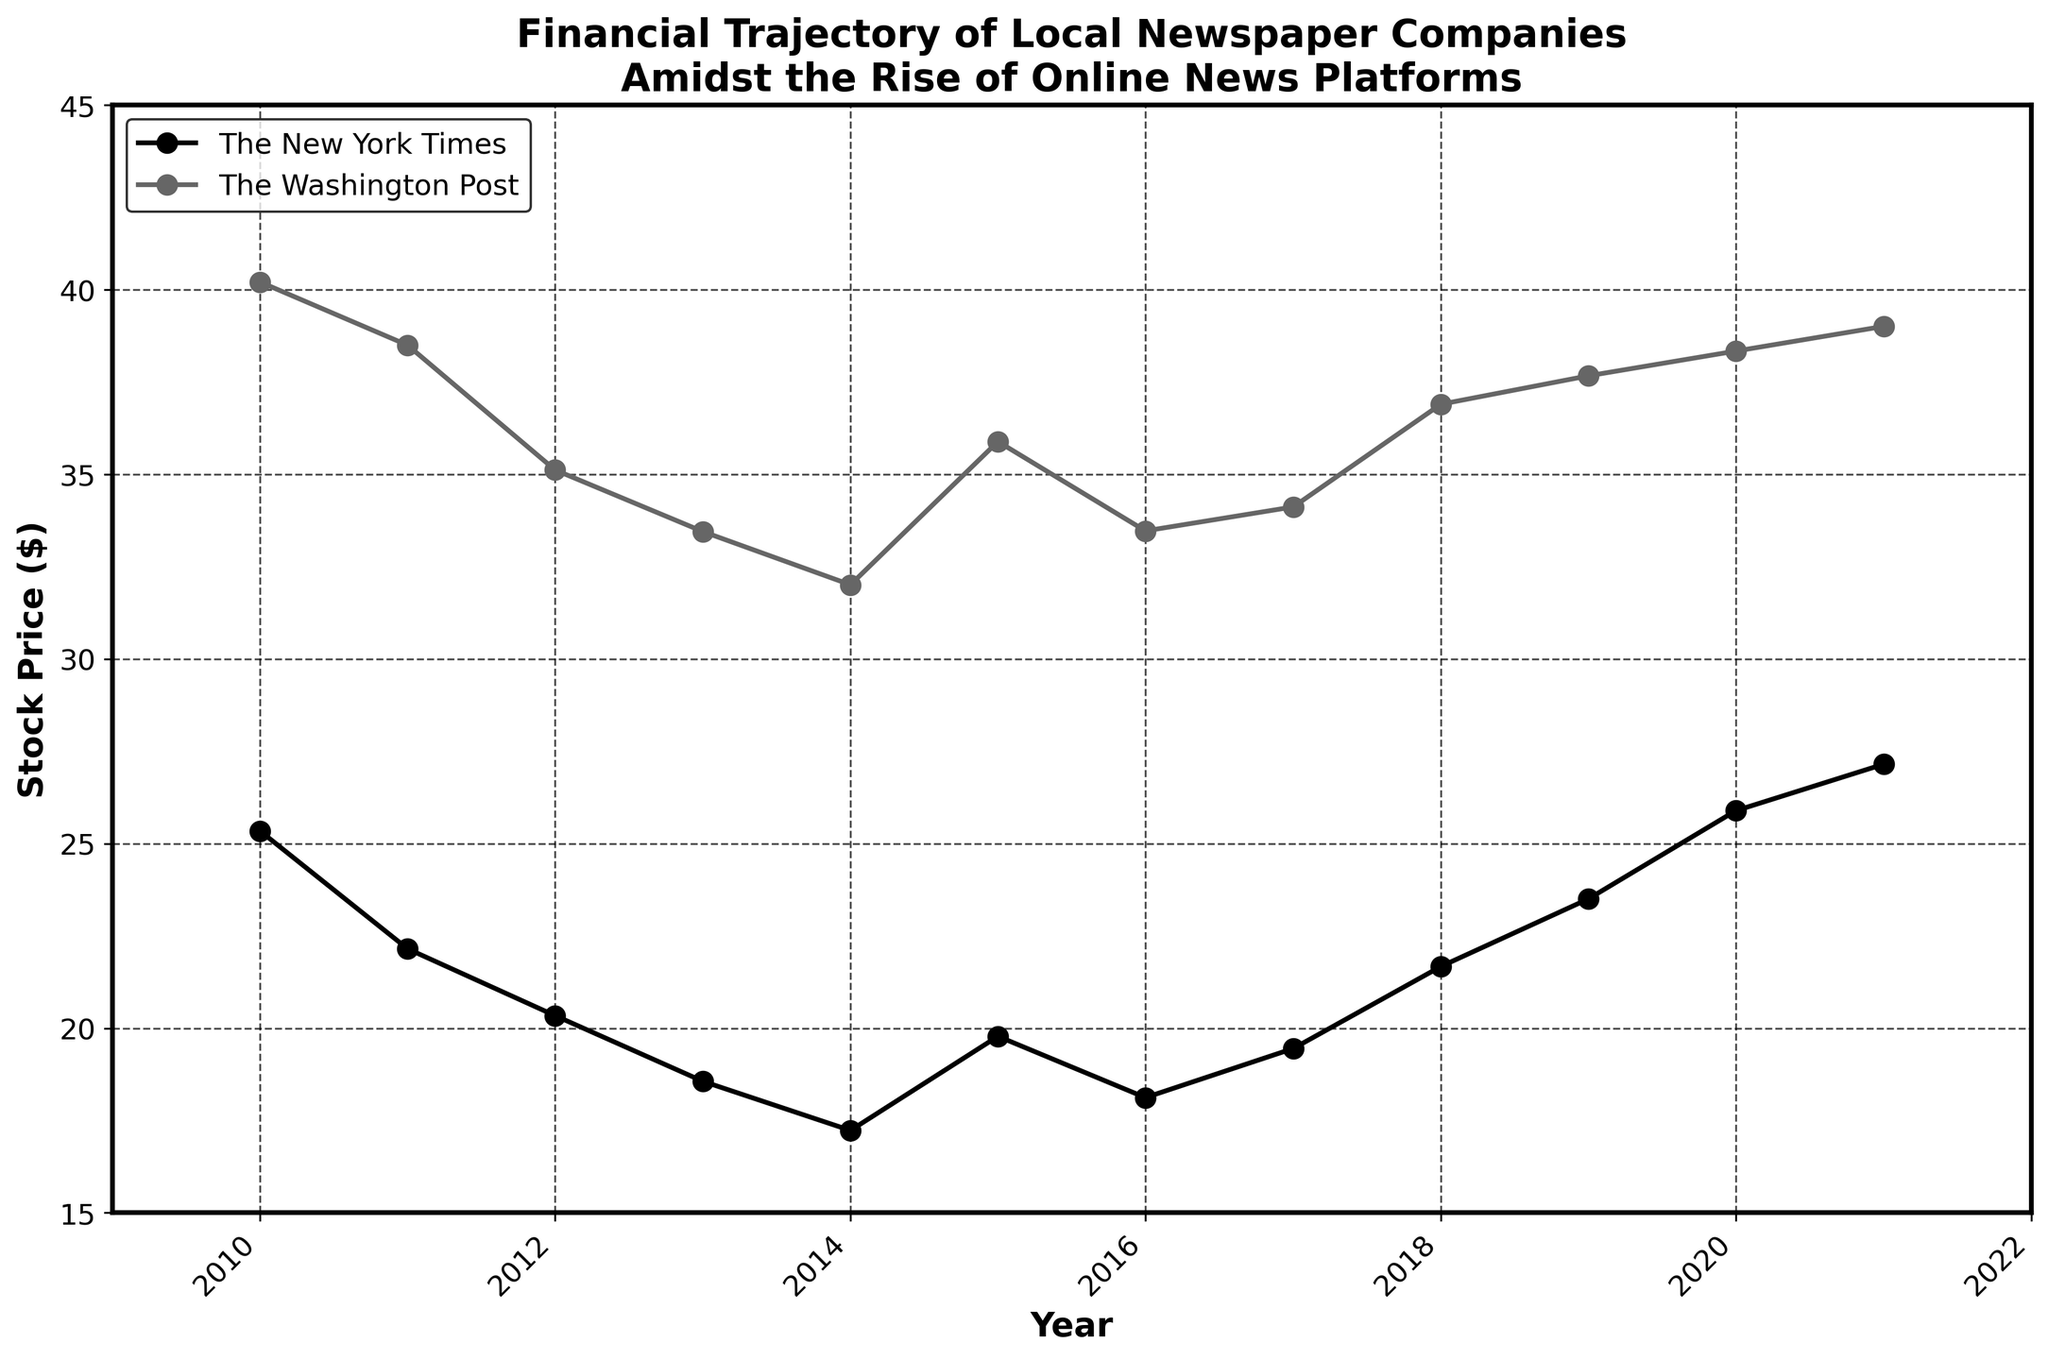what is the overall trend for The New York Times' stock price from 2010 to 2021? The plot shows the stock prices for The New York Times from 2010 to 2021. Visually tracing the curve, we observe that the stock price initially declines from 2010 to 2014, reaching a low around 2014. From 2015 onward, the price shows an upward trend, ending higher in 2021 compared to 2010.
Answer: The overall trend is a decline followed by an upward trend What's the lowest recorded stock price for The Washington Post during the observation period? By examining the plot for The Washington Post, the lowest point appears around 2014, where the stock price is near $32.01.
Answer: $32.01 Compare the stock prices of both companies in 2015. Which company had a higher stock price? Referring to the points plotted for the year 2015, The New York Times has a stock price of $19.78, while The Washington Post has a stock price of $35.89, which is higher.
Answer: The Washington Post How does the variation in stock price for The New York Times compare to that of The Washington Post from 2015 to 2021? To determine the variation, observe the difference between the stock prices at these two endpoints for each company. For The New York Times, the difference is 27.15 - 19.78 = 7.37. For The Washington Post, it is 39.01 - 35.89 = 3.12. The variation for The New York Times is higher.
Answer: The New York Times has a greater variation What is the average stock price for The New York Times over the observed period? To calculate the average, sum all stock prices of The New York Times and divide by the number of years. The sum is 25.34 + 22.15 + 20.34 + 18.56 + 17.23 + 19.78 + 18.12 + 19.45 + 21.67 + 23.50 + 25.89 + 27.15 = 259.18. There are 12 points, so the average is 259.18/12 = 21.60.
Answer: $21.60 What year saw the largest increase in stock price for The Washington Post from the previous year? By inspecting the differences year-on-year, the largest increase appears between 2014 ($32.01) and 2015 ($35.89), which is an increase of 3.88.
Answer: 2015 Has any stock price declined for The New York Times after 2019? By analyzing the points from 2019 onward for The New York Times, all points from 2019 to 2021 show an increase.
Answer: No What is the difference in stock price between the highest and lowest recorded points for The Washington Post? The highest recorded is $40.21 (2010), and the lowest is $32.01 (2014). The difference is 40.21 - 32.01 = 8.20.
Answer: $8.20 